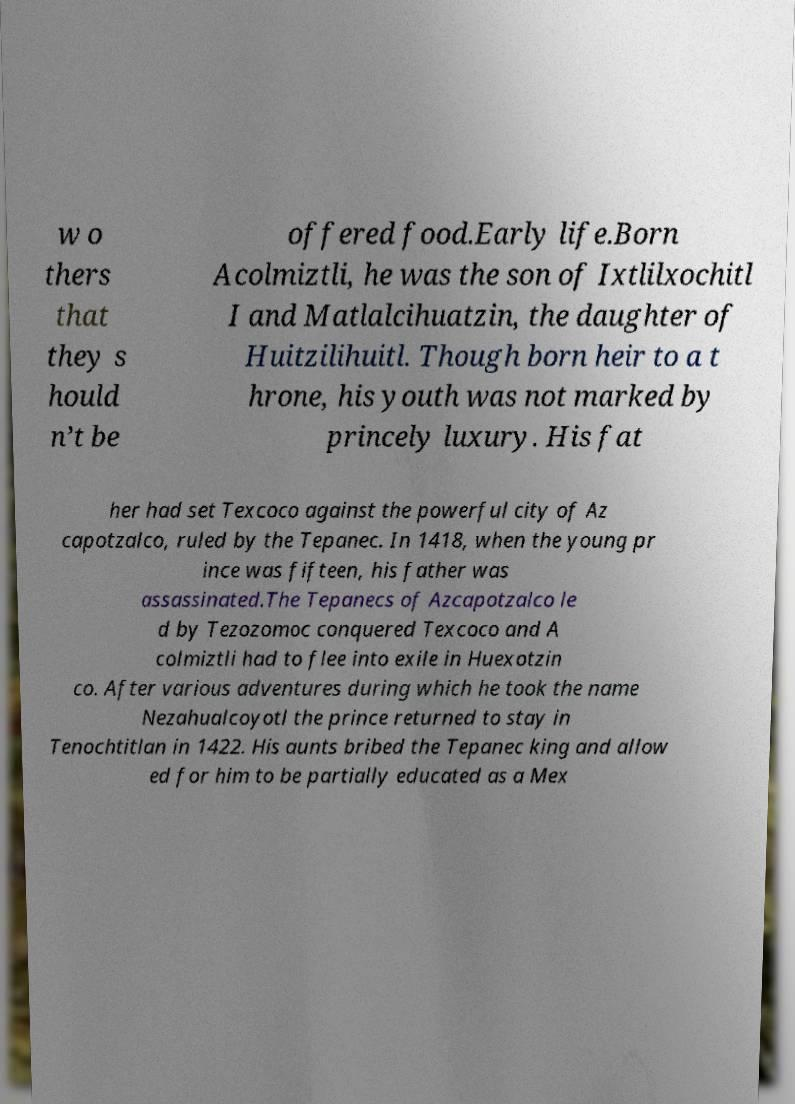For documentation purposes, I need the text within this image transcribed. Could you provide that? w o thers that they s hould n’t be offered food.Early life.Born Acolmiztli, he was the son of Ixtlilxochitl I and Matlalcihuatzin, the daughter of Huitzilihuitl. Though born heir to a t hrone, his youth was not marked by princely luxury. His fat her had set Texcoco against the powerful city of Az capotzalco, ruled by the Tepanec. In 1418, when the young pr ince was fifteen, his father was assassinated.The Tepanecs of Azcapotzalco le d by Tezozomoc conquered Texcoco and A colmiztli had to flee into exile in Huexotzin co. After various adventures during which he took the name Nezahualcoyotl the prince returned to stay in Tenochtitlan in 1422. His aunts bribed the Tepanec king and allow ed for him to be partially educated as a Mex 